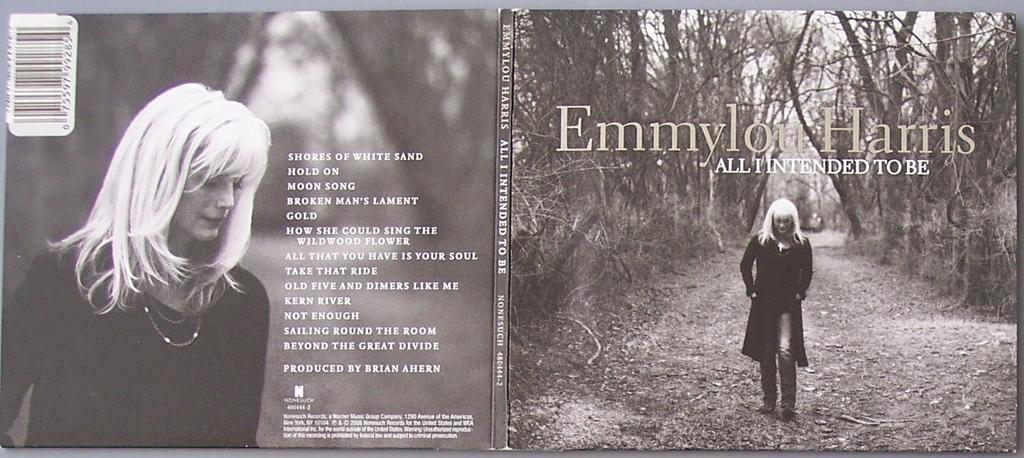Can you describe this image briefly? In the picture we can see a magazine on it, we can see an image of a woman and some information beside her and name on it Emmylou Harris and on the top of it we can see a bar code. 